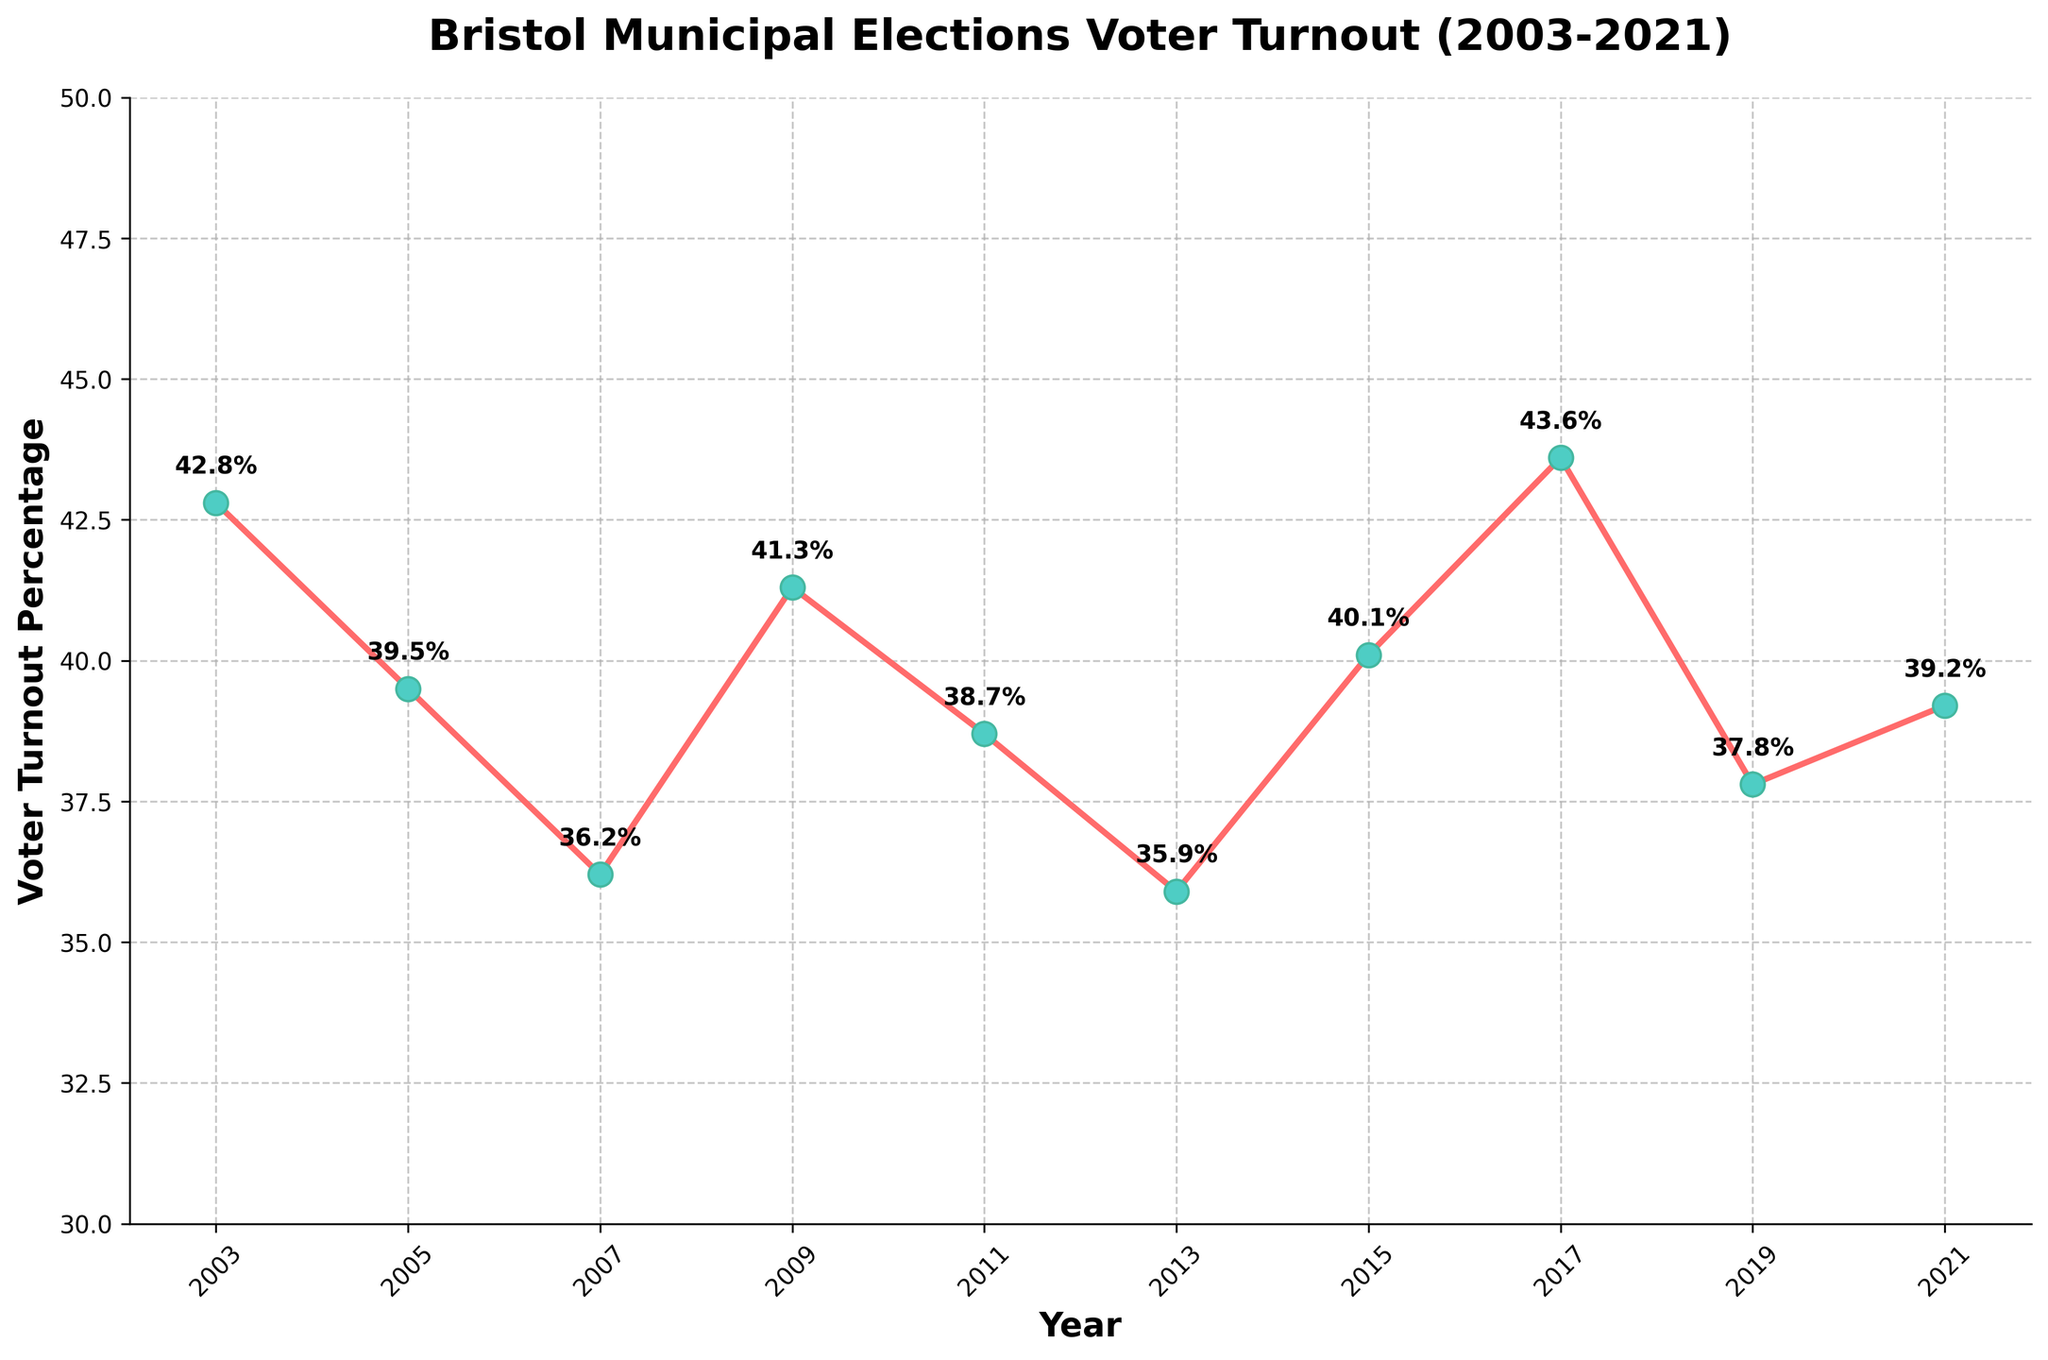Which year had the highest voter turnout? The highest voter turnout percentage can be found by scanning the vertical positions of the plotted points. The highest point on the y-axis corresponds to 43.6% in 2017.
Answer: 2017 What is the average voter turnout percentage over the 20-year period? To find the average, sum all the voter turnout percentages and divide by the number of years (10 years). (42.8 + 39.5 + 36.2 + 41.3 + 38.7 + 35.9 + 40.1 + 43.6 + 37.8 + 39.2) / 10 = 395.1 / 10 = 39.51%
Answer: 39.51% Between which two consecutive years was the largest increase in voter turnout? Compare the differences in voter turnout percentages between consecutive years. The largest increase occurs between 2015 and 2017, where the percentage rises from 40.1% to 43.6%, an increase of 3.5%.
Answer: 2015 to 2017 Which year had the lowest voter turnout, and what was the percentage? The lowest voter turnout percentage can be identified by locating the lowest point on the y-axis. The lowest point corresponds to 35.9% in 2013.
Answer: 2013, 35.9% What is the trend in voter turnout between 2003 and 2007? Observe the slope of the plotted line from 2003 to 2007. The turnout consistently decreases from 42.8% in 2003 to 36.2% in 2007, indicating a downward trend.
Answer: Decreasing How many times did the voter turnout go above 40%? Count the number of data points where the voter turnout percentage is above 40%. These occur at 42.8%, 41.3%, 40.1%, and 43.6%, for a total of four times.
Answer: 4 times What is the median voter turnout percentage over the 20-year period? To find the median, list the voter turnout percentages in ascending order: (35.9, 36.2, 37.8, 38.7, 39.2, 39.5, 40.1, 41.3, 42.8, 43.6). The median is the average of the 5th and 6th values: (39.2 + 39.5) / 2 = 39.35%.
Answer: 39.35% Which year had a voter turnout percentage closest to the average voter turnout of 39.51%? Compare each year's voter turnout percentage to the average of 39.51%. The closest is 39.5% in 2005.
Answer: 2005 By how much did the voter turnout change from 2003 to 2005? Subtract the 2005 voter turnout percentage from the 2003 percentage. 42.8% - 39.5% = 3.3%.
Answer: 3.3% Between 2011 and 2013, did the voter turnout increase or decrease, and by how much? Subtract the 2013 turnout percentage from the 2011 percentage. 38.7% - 35.9% = 2.8%, indicating a decrease.
Answer: Decrease, 2.8% 